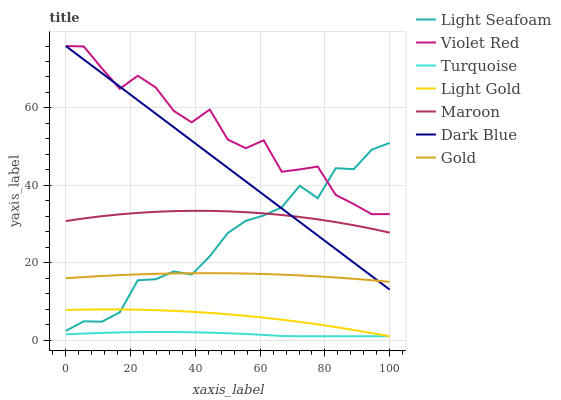Does Turquoise have the minimum area under the curve?
Answer yes or no. Yes. Does Violet Red have the maximum area under the curve?
Answer yes or no. Yes. Does Gold have the minimum area under the curve?
Answer yes or no. No. Does Gold have the maximum area under the curve?
Answer yes or no. No. Is Dark Blue the smoothest?
Answer yes or no. Yes. Is Violet Red the roughest?
Answer yes or no. Yes. Is Gold the smoothest?
Answer yes or no. No. Is Gold the roughest?
Answer yes or no. No. Does Gold have the lowest value?
Answer yes or no. No. Does Dark Blue have the highest value?
Answer yes or no. Yes. Does Gold have the highest value?
Answer yes or no. No. Is Light Gold less than Violet Red?
Answer yes or no. Yes. Is Maroon greater than Light Gold?
Answer yes or no. Yes. Does Light Seafoam intersect Dark Blue?
Answer yes or no. Yes. Is Light Seafoam less than Dark Blue?
Answer yes or no. No. Is Light Seafoam greater than Dark Blue?
Answer yes or no. No. Does Light Gold intersect Violet Red?
Answer yes or no. No. 